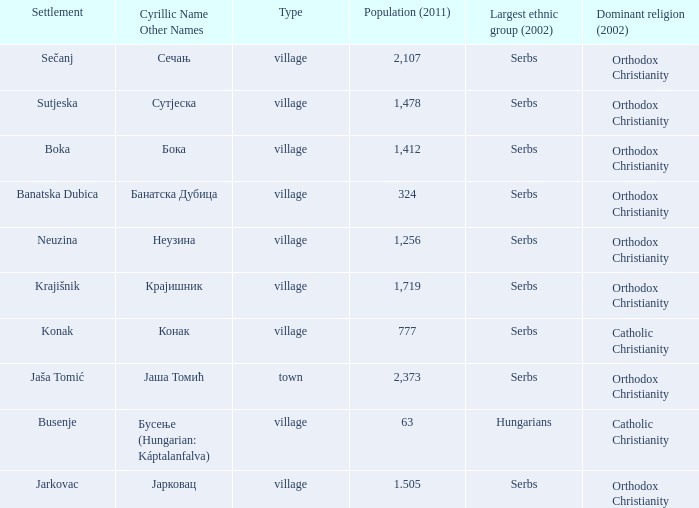What is the ethnic group is конак? Serbs. 